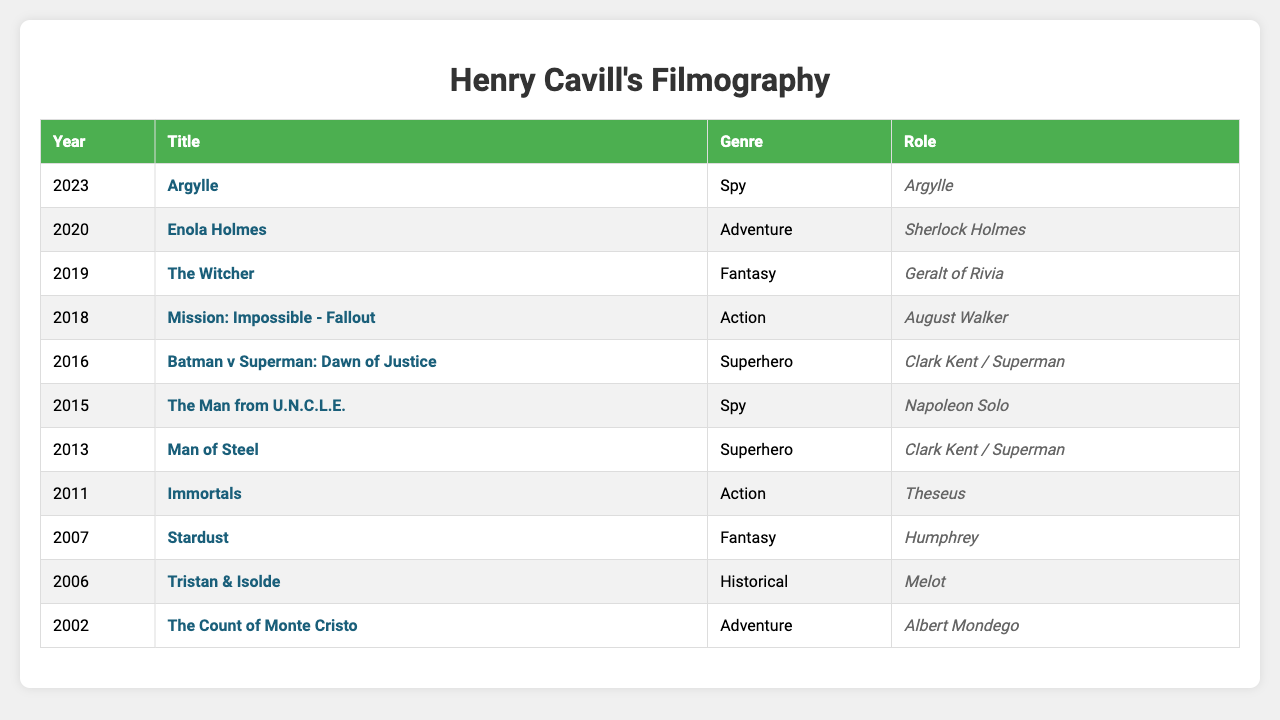What year did Henry Cavill star in "Man of Steel"? The table indicates that "Man of Steel" was released in the year 2013.
Answer: 2013 Which genre appears most frequently in Henry Cavill's filmography? By reviewing the genres listed, "Superhero" and "Action" both appear two times, while the rest appear once; thus, both have the highest frequency.
Answer: Superhero and Action How many films did Henry Cavill release in 2016? In the table, there are two films listed in 2016: "Batman v Superman: Dawn of Justice" and "The Man from U.N.C.L.E". Therefore, the count is 2.
Answer: 2 What's the total number of movies in the Action genre? The table lists three movies under the Action genre: "Immortals", "Mission: Impossible - Fallout", and "Batman v Superman: Dawn of Justice", hence the total is 3.
Answer: 3 Did Henry Cavill appear in any Comedy films? Looking at the genres in the table, there is no mention of a Comedy film featuring Henry Cavill in his filmography.
Answer: No Which movie has the earliest release date and what is its genre? The earliest release date in the table is for "The Count of Monte Cristo," which came out in 2002 and falls under the Adventure genre.
Answer: The Count of Monte Cristo, Adventure What is the average year of release for Henry Cavill's films in the Superhero genre? There are two Superhero films: "Man of Steel" (2013) and "Batman v Superman: Dawn of Justice" (2016). The average year is (2013 + 2016) / 2 = 2014.5, which rounds to 2015.
Answer: 2015 Which movies did Henry Cavill star in after 2015? The movies released after 2015 in the table are: "Batman v Superman: Dawn of Justice" (2016), "Mission: Impossible - Fallout" (2018), "Enola Holmes" (2020), and "Argylle" (2023), totaling four films.
Answer: 4 What roles did Henry Cavill play in the Fantasy genre? The table shows two Fantasy movies, "Stardust" where he played Humphrey and "The Witcher", where he played Geralt of Rivia.
Answer: Humphrey and Geralt of Rivia Is there a film in Henry Cavill's filmography that is both Action and Superhero? Analyzing the genres, "Batman v Superman: Dawn of Justice" represents both the Action and Superhero genres, confirming its dual classification.
Answer: Yes 